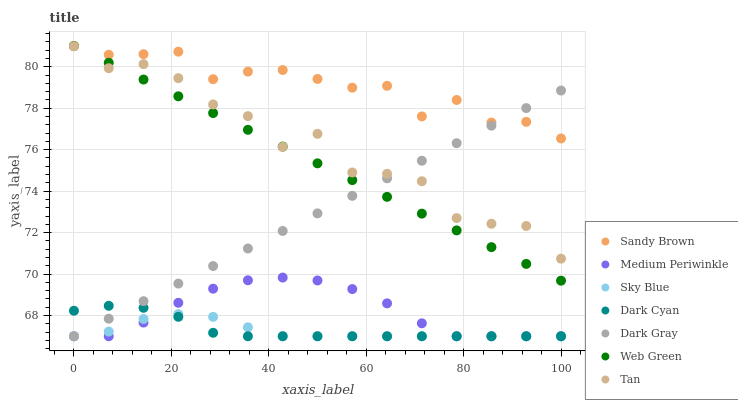Does Sky Blue have the minimum area under the curve?
Answer yes or no. Yes. Does Sandy Brown have the maximum area under the curve?
Answer yes or no. Yes. Does Web Green have the minimum area under the curve?
Answer yes or no. No. Does Web Green have the maximum area under the curve?
Answer yes or no. No. Is Web Green the smoothest?
Answer yes or no. Yes. Is Tan the roughest?
Answer yes or no. Yes. Is Dark Gray the smoothest?
Answer yes or no. No. Is Dark Gray the roughest?
Answer yes or no. No. Does Medium Periwinkle have the lowest value?
Answer yes or no. Yes. Does Web Green have the lowest value?
Answer yes or no. No. Does Sandy Brown have the highest value?
Answer yes or no. Yes. Does Dark Gray have the highest value?
Answer yes or no. No. Is Dark Cyan less than Sandy Brown?
Answer yes or no. Yes. Is Sandy Brown greater than Dark Cyan?
Answer yes or no. Yes. Does Dark Cyan intersect Sky Blue?
Answer yes or no. Yes. Is Dark Cyan less than Sky Blue?
Answer yes or no. No. Is Dark Cyan greater than Sky Blue?
Answer yes or no. No. Does Dark Cyan intersect Sandy Brown?
Answer yes or no. No. 